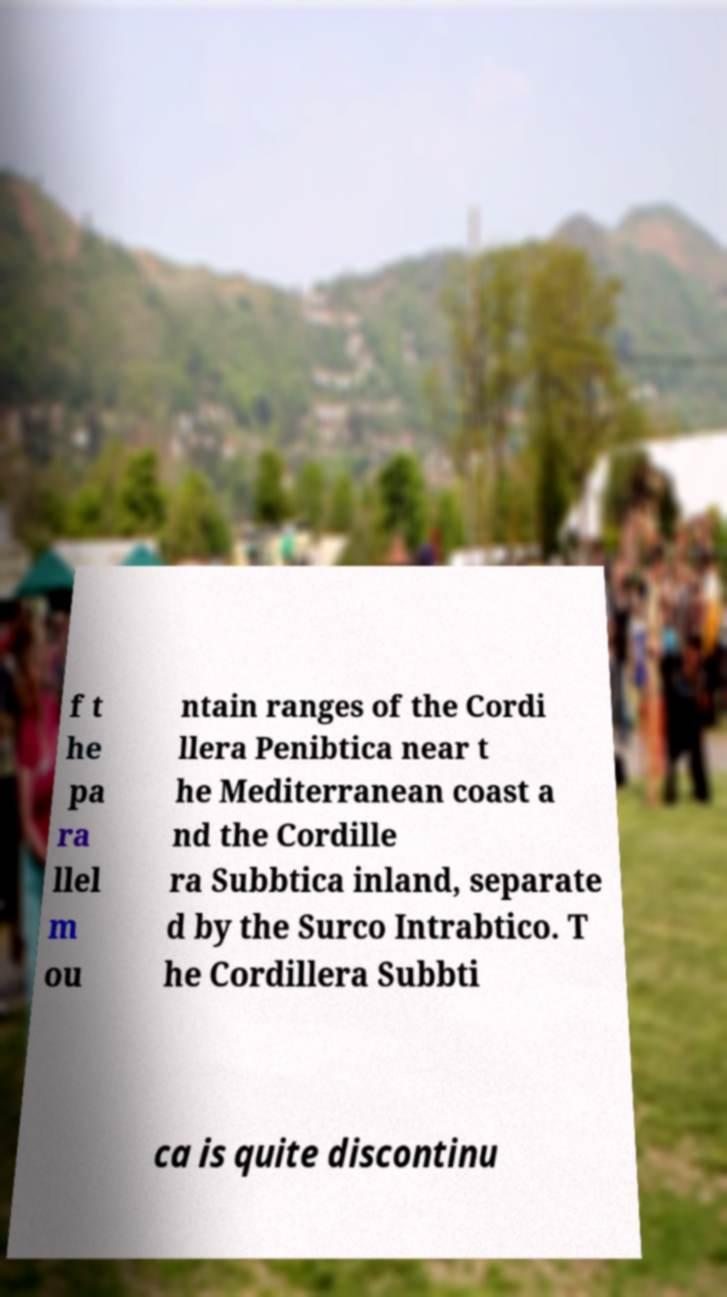Can you read and provide the text displayed in the image?This photo seems to have some interesting text. Can you extract and type it out for me? f t he pa ra llel m ou ntain ranges of the Cordi llera Penibtica near t he Mediterranean coast a nd the Cordille ra Subbtica inland, separate d by the Surco Intrabtico. T he Cordillera Subbti ca is quite discontinu 